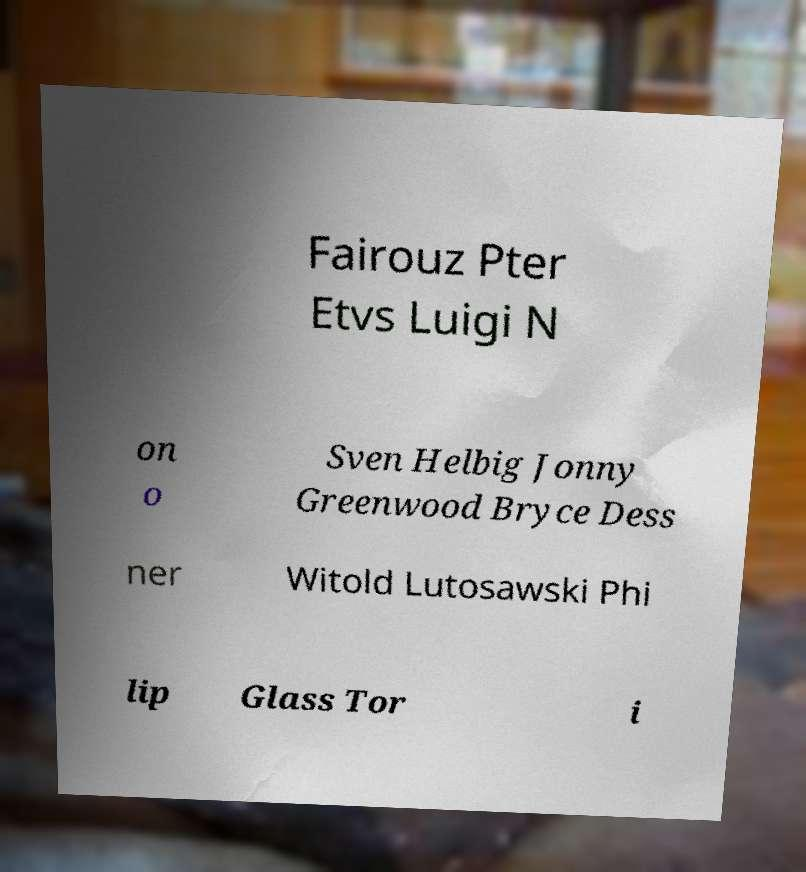I need the written content from this picture converted into text. Can you do that? Fairouz Pter Etvs Luigi N on o Sven Helbig Jonny Greenwood Bryce Dess ner Witold Lutosawski Phi lip Glass Tor i 